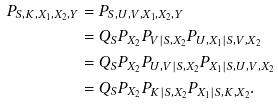<formula> <loc_0><loc_0><loc_500><loc_500>P _ { S , K , X _ { 1 } , X _ { 2 } , Y } & = P _ { S , U , V , X _ { 1 } , X _ { 2 } , Y } \\ & = Q _ { S } P _ { X _ { 2 } } P _ { V | S , X _ { 2 } } P _ { U , X _ { 1 } | S , V , X _ { 2 } } \\ & = Q _ { S } P _ { X _ { 2 } } P _ { U , V | S , X _ { 2 } } P _ { X _ { 1 } | S , U , V , X _ { 2 } } \\ & = Q _ { S } P _ { X _ { 2 } } P _ { K | S , X _ { 2 } } P _ { X _ { 1 } | S , K , X _ { 2 } } .</formula> 